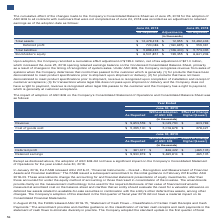According to Lam Research Corporation's financial document, How did the Company adopt the ASU 2018-02, “Reclassification of Certain Tax Effects from Accumulated Other Comprehensive Income" standard? Based on the financial document, the answer is using a modified-retrospective approach through a cumulative-effect adjustment directly to retained earnings. Also, What did the adoption of the standard result in? Based on the financial document, the answer is a $2.2 million increase to retained earnings, with a corresponding $2.2 million decrease to other comprehensive income. Also, What did the adoption of the amendments result in? Based on the financial document, the answer is minor changes within its Consolidated Financial Statements. Also, can you calculate: What is the gross profit as reported in 2019? Based on the calculation: 9,653,559-5,295,100, the result is 4358459 (in thousands). This is based on the information: "Revenue $ 9,653,559 $ 9,049,790 $ 603,769 Cost of goods sold $ 5,295,100 $ 5,016,679 $ 278,421..." The key data points involved are: 5,295,100, 9,653,559. Also, can you calculate: What is the gross profit ratio as reported in 2019? To answer this question, I need to perform calculations using the financial data. The calculation is: (9,653,559-5,295,100)/9,653,559, which equals 45.15 (percentage). This is based on the information: "Revenue $ 9,653,559 $ 9,049,790 $ 603,769 Cost of goods sold $ 5,295,100 $ 5,016,679 $ 278,421..." The key data points involved are: 5,295,100, 9,653,559. Also, can you calculate: What is the percentage change in the revenue after the adoption of ASC606? To answer this question, I need to perform calculations using the financial data. The calculation is: (9,653,559-9,049,790)/9,049,790, which equals 6.67 (percentage). This is based on the information: "Revenue $ 9,653,559 $ 9,049,790 $ 603,769 Revenue $ 9,653,559 $ 9,049,790 $ 603,769..." The key data points involved are: 9,049,790, 9,653,559. 